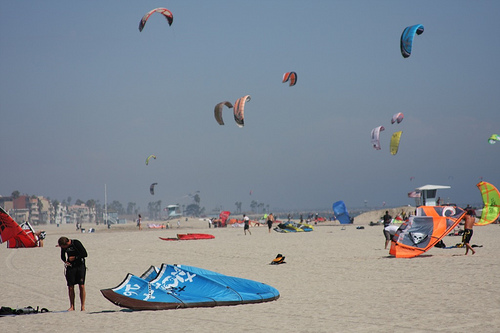<image>What country does the emblem on the chute represent? It is ambiguous which country the emblem on the chute represents. It could possibly represent Japan, Israel, United States, France, Colombia, or Wales. What country does the emblem on the chute represent? I am not sure what country does the emblem on the chute represent. It can be seen 'japan', 'israel', 'united states', 'france', 'usa', 'usa', 'unknown', 'usa', 'colombia' or 'wales'. 